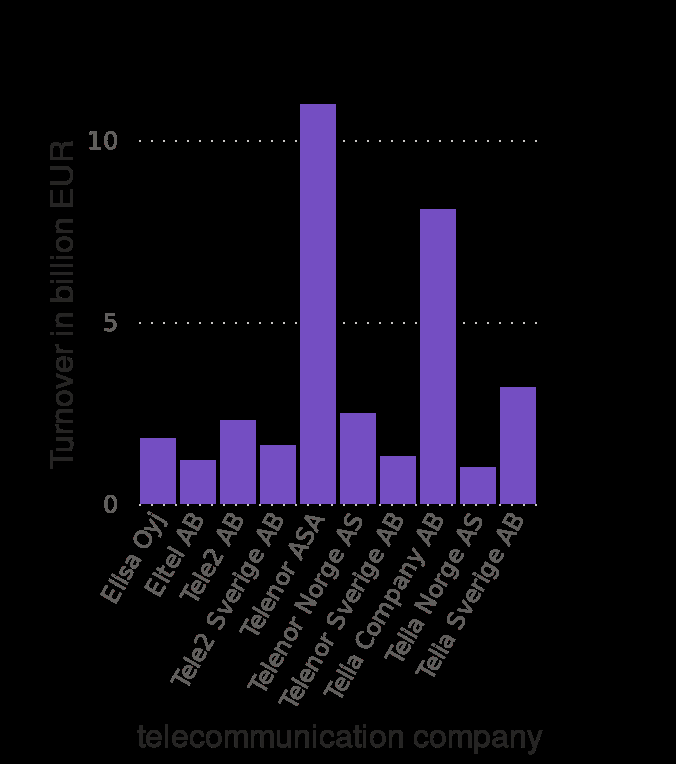<image>
Which company is shown last on the x-axis?  The last company is not mentioned in the description. How many companies follow the one that owns the biggest share of the martlet?  Two other companies follow the one that owns the biggest share of the martlet. What is the highest turnover shown on the y-axis?  10 billion EUR 